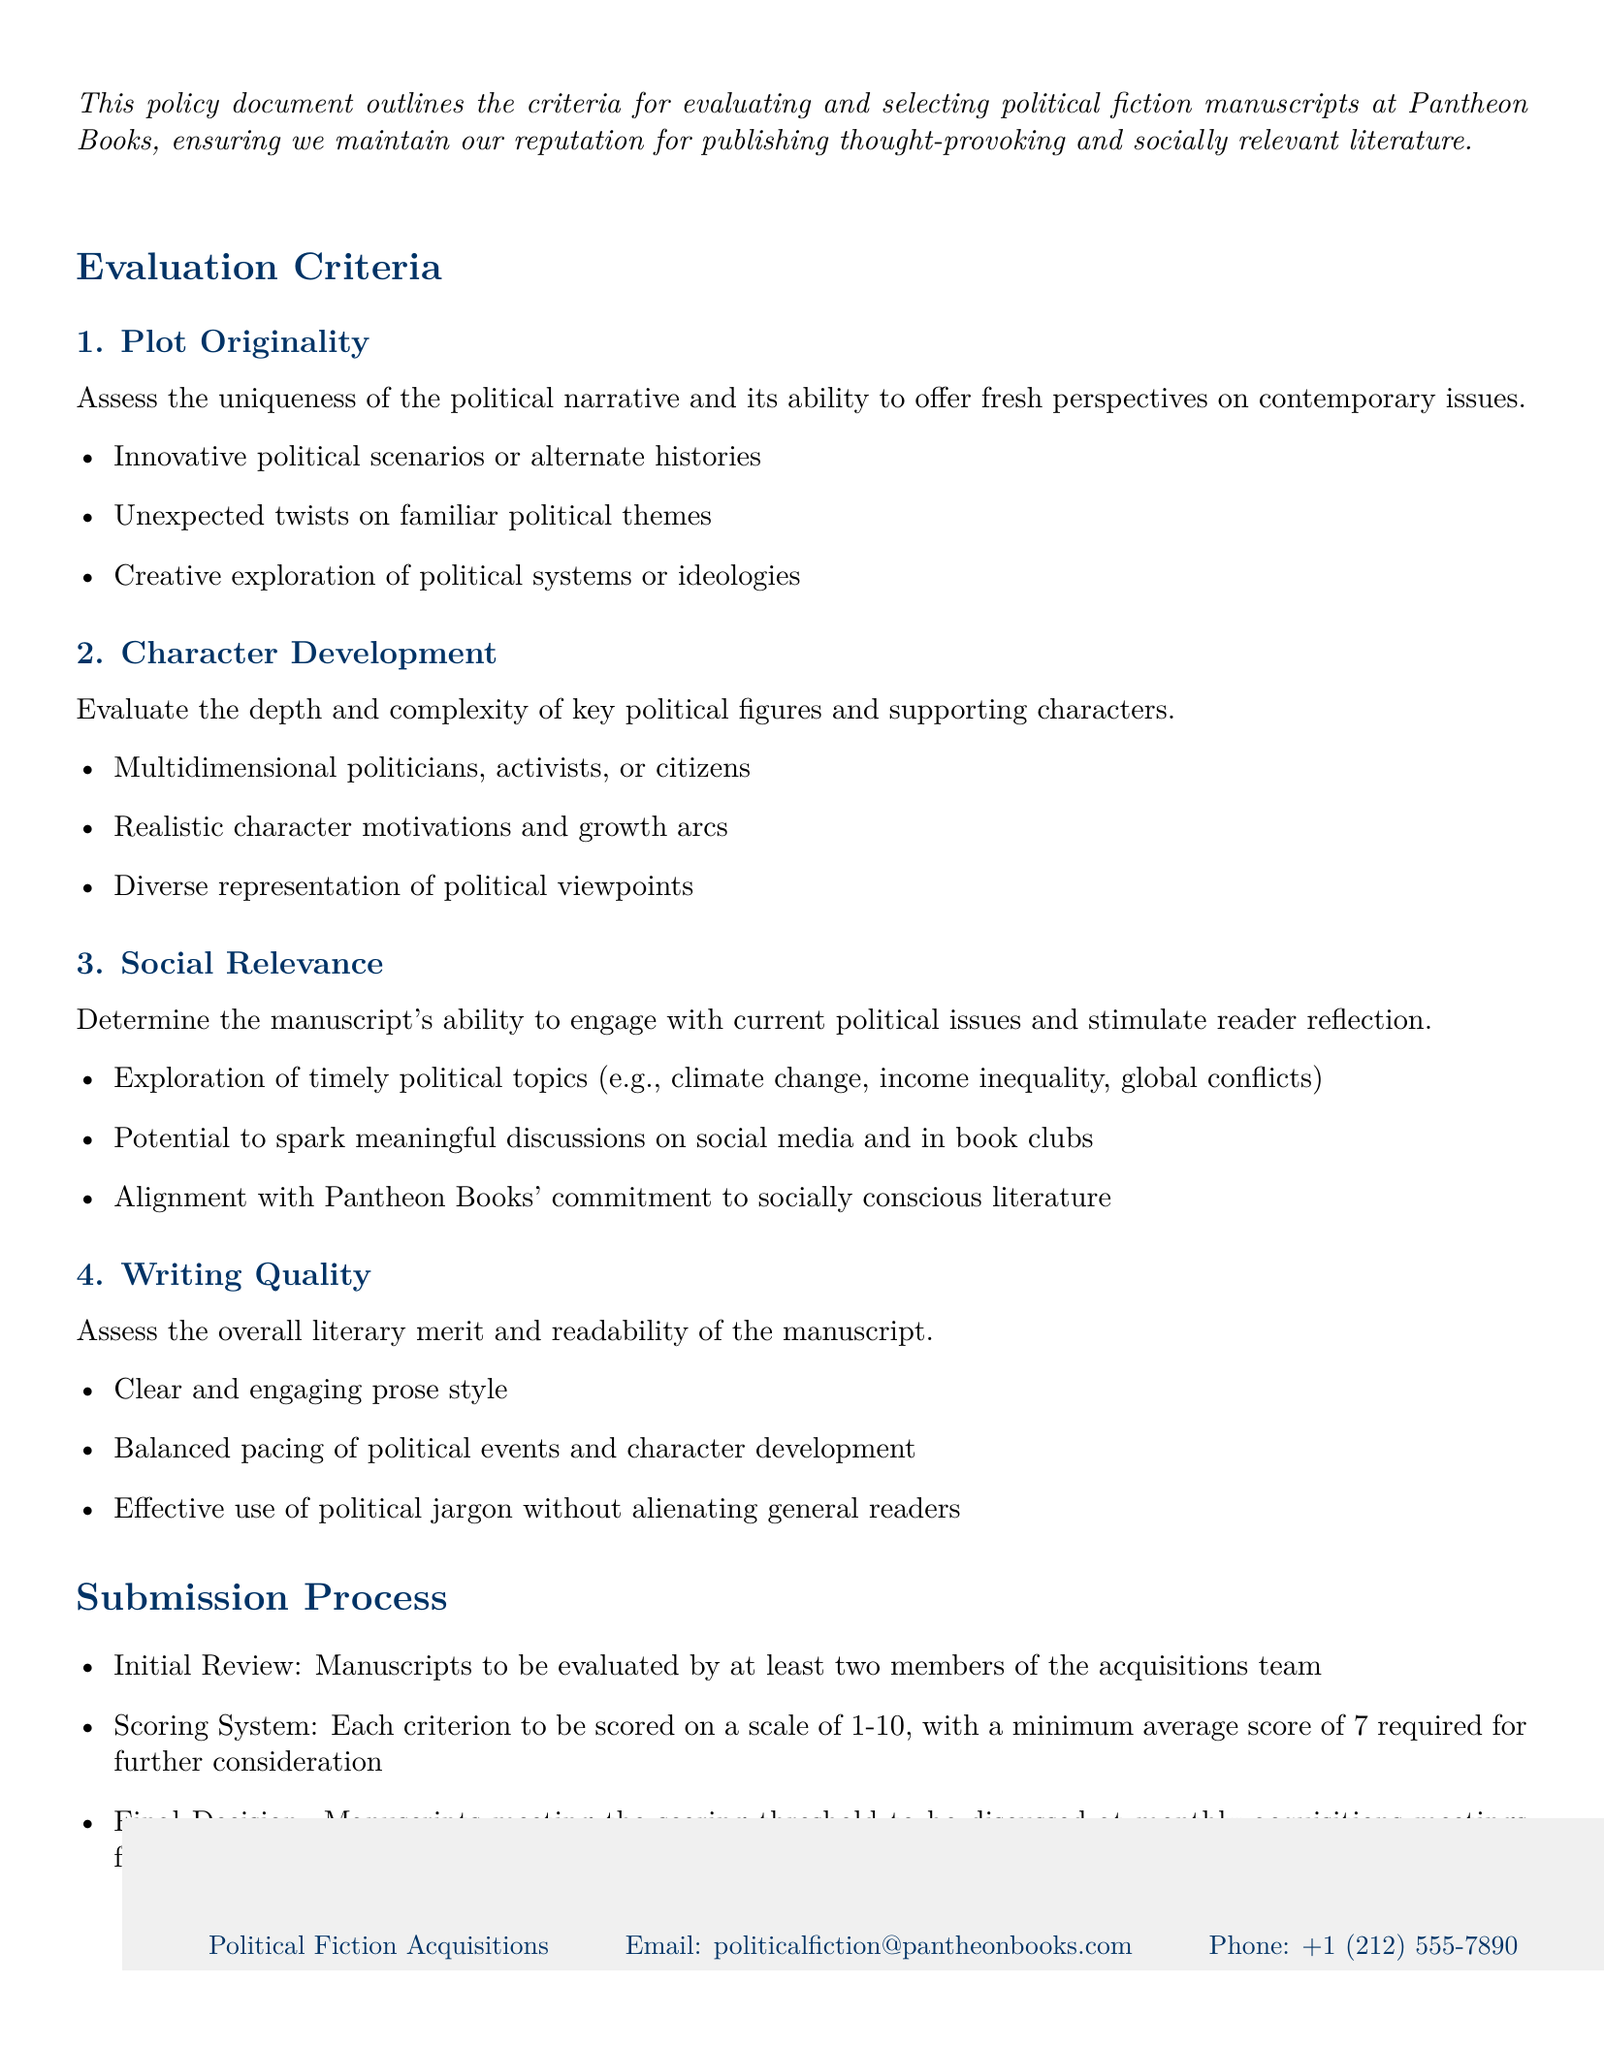What is the title of the document? The title of the document, prominently stated at the top, is "Manuscript Evaluation Criteria for Political Fiction."
Answer: Manuscript Evaluation Criteria for Political Fiction How many evaluation criteria are listed? The document includes a specific section that enumerates the criteria, which totals four main criteria listed.
Answer: 4 What is the minimum average score required for further consideration? The scoring system mentioned in the document specifies a minimum average score that must be achieved for a manuscript to move forward in the selection process.
Answer: 7 What type of characters are highlighted under "Character Development"? The document mentions specific qualities that characters should possess, including being multidimensional, which defines the required complexity of characters in the manuscripts.
Answer: Multidimensional Which issue is mentioned under "Social Relevance"? The document lists themes that manuscripts should explore to be relevant, including a specific social challenge that is timely and significant to contemporary discussions.
Answer: Climate change What is the purpose of the initial review? The initial review serves as the first step in the selection process, as outlined in the submission process section, where manuscripts are evaluated to determine their potential.
Answer: Evaluate manuscripts What is the department handling the manuscript submissions? The footer of the document lists the specific division responsible for acquiring the political fiction manuscripts at Pantheon Books.
Answer: Political Fiction Acquisitions What kind of prose style is assessed in the "Writing Quality" criterion? The document specifies a particular type of writing quality that ensures engagement and clarity throughout the manuscript.
Answer: Clear and engaging prose style How many members evaluate the manuscripts during the initial review? The document clearly states the number of team members required to evaluate each manuscript at the first stage of the review process.
Answer: At least two 